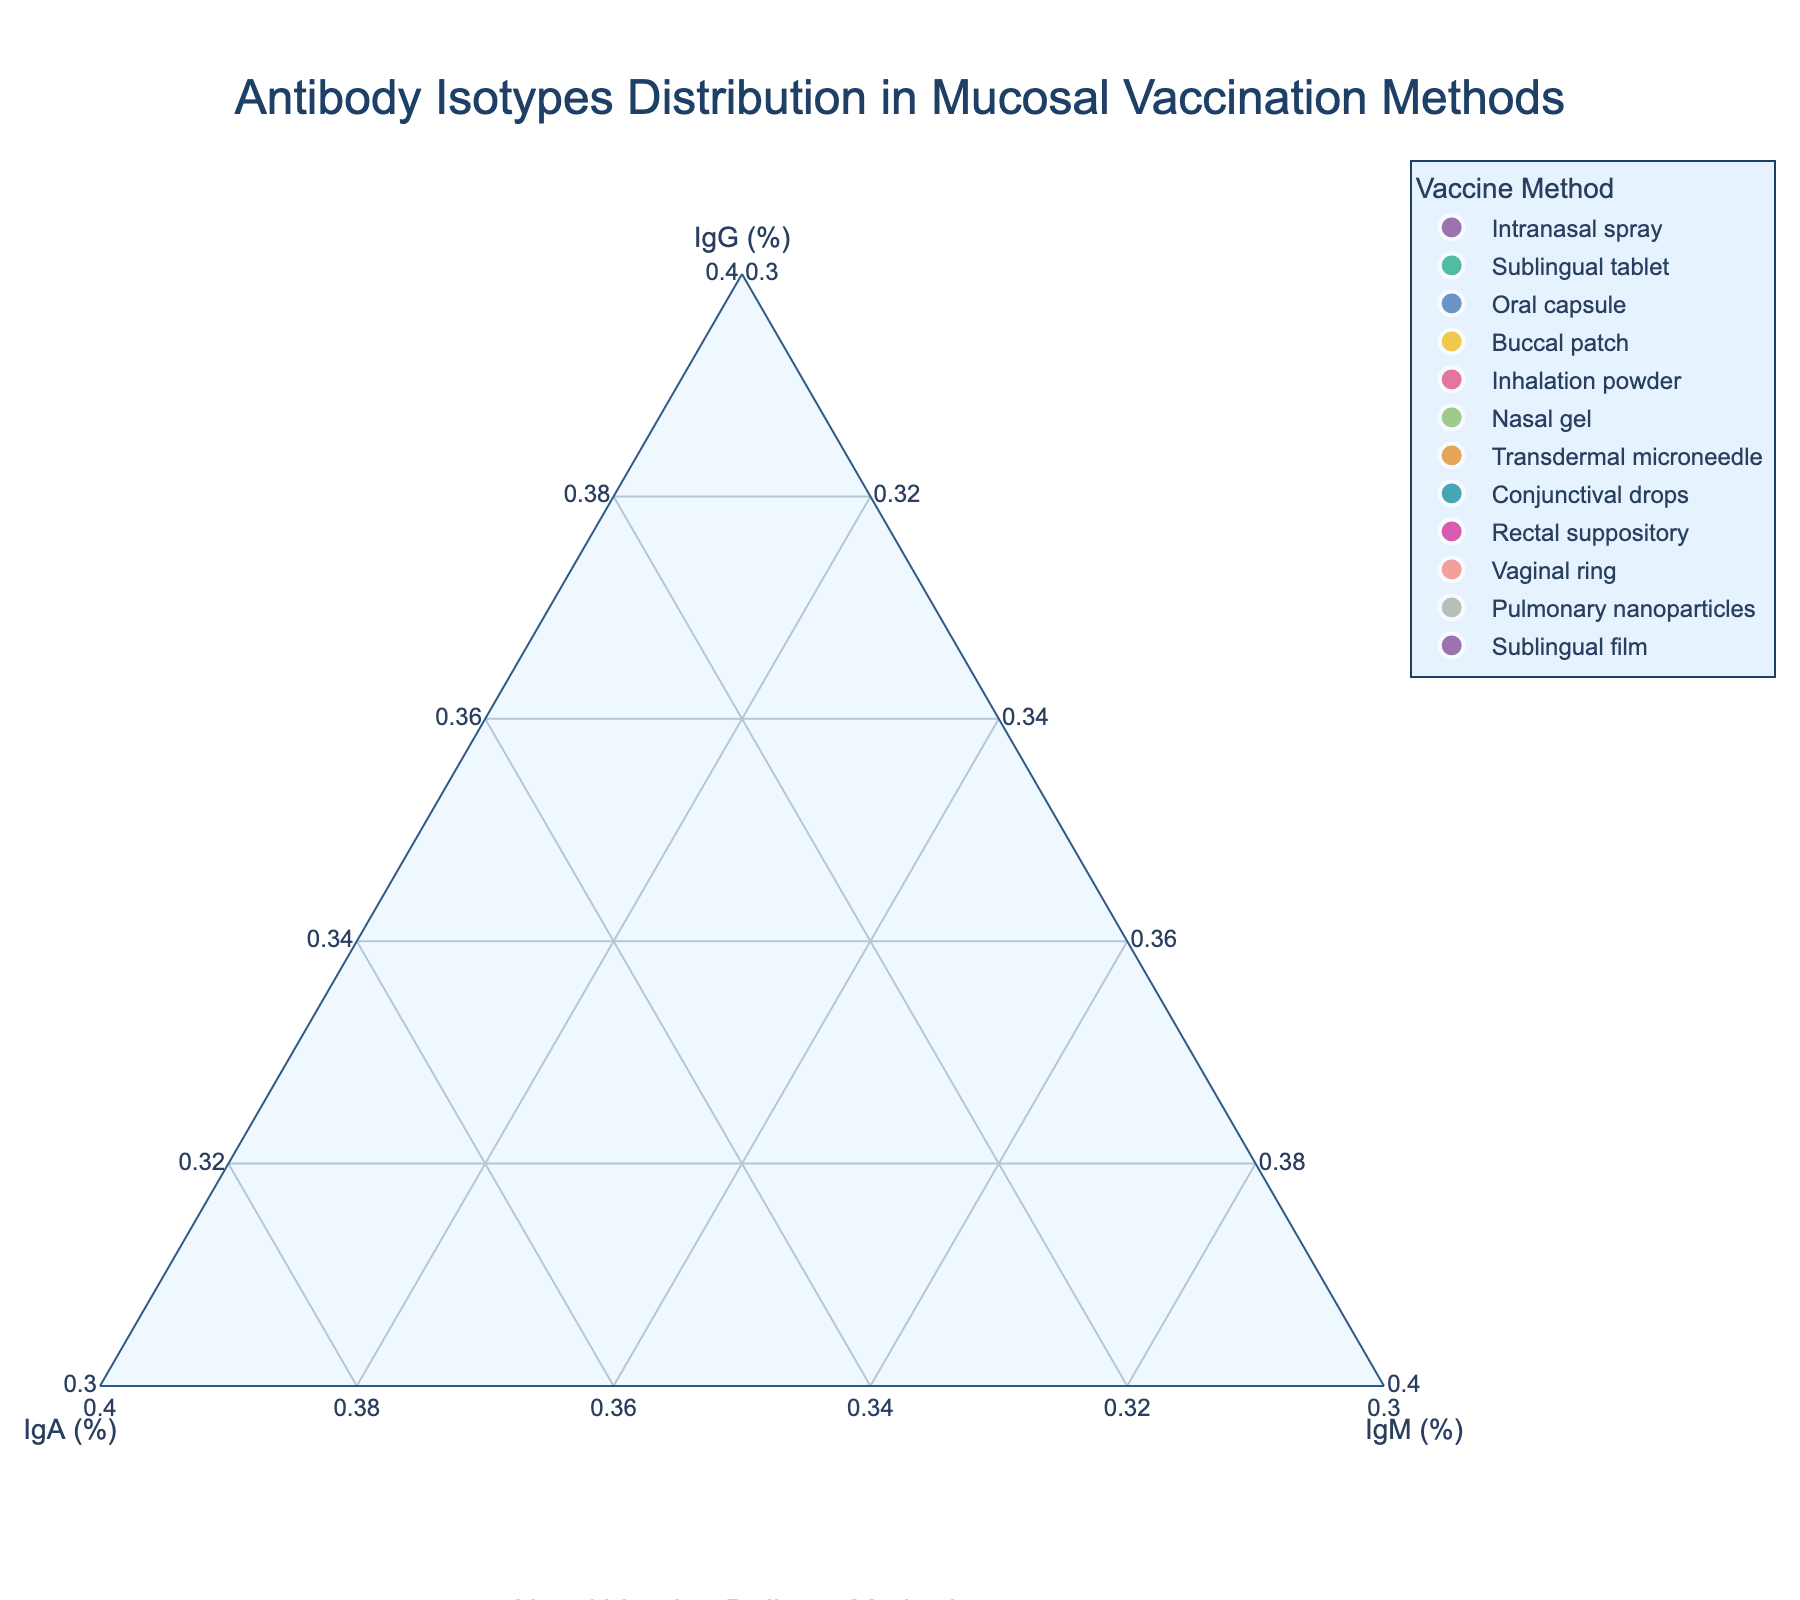What is the title of the figure? The title is usually at the top of the figure. Here, the title appears centered and in a larger font size, making it easy to spot.
Answer: Antibody Isotypes Distribution in Mucosal Vaccination Methods Which vaccine method has the highest proportion of IgG? By examining the IgG axis at the bottom-left corner and looking for the data point closest to the IgG apex, we can identify the vaccine method. The method with the highest percentage at the IgG apex is labeled correctly.
Answer: Transdermal microneedle How many vaccine methods have an IgA proportion greater than 40%? By inspecting the IgA axis (bottom-right side) for data points greater than 40% and counting them, we determine the number of vaccine methods satisfying the condition.
Answer: 2 Which vaccine method has the most balanced proportions of IgG, IgA, and IgM? The most balanced data point would be near the center of the ternary plot. By observing which data point is closest to being equidistant from all three axes, we find the answer.
Answer: Buccal patch Which vaccine method exhibits the smallest proportion of IgM? By examining the IgM axis (left side) and identifying which data point lies closest to the IgM axis at the least value, we can determine the vaccine method.
Answer: Pulmonary nanoparticles Compare the IgA proportions between Nasal gel and Rectal suppository. Which one is higher? We look at the IgA values for Nasal gel and Rectal suppository on the ternary plot. The vaccine method with the point higher on the IgA axis will have the greater proportion of IgA.
Answer: Nasal gel Which three vaccine methods have IgG proportions closest to 60%? Inspect the area around the 60% mark on the IgG axis and identify the three vaccine methods whose data points are closest to this mark.
Answer: Vaginal ring, Inhalation powder, Intranasal spray Are there any vaccine methods where the proportion of IgM is greater than 15%? By checking the data points on the IgM axis, we examine if any points lie above the 15% mark. If found, we confirm the presence.
Answer: No What is the sum of IgA and IgM proportions for the Rectal suppository? Check the proportions of IgA and IgM for Rectal suppository and sum these values.
Answer: 35 + 10 = 45 Identify the vaccine method with the highest cumulative proportions of IgG and IgA. Calculate the sums of IgG and IgA for all vaccine methods and find the method with the highest value.
Answer: Oral capsule 